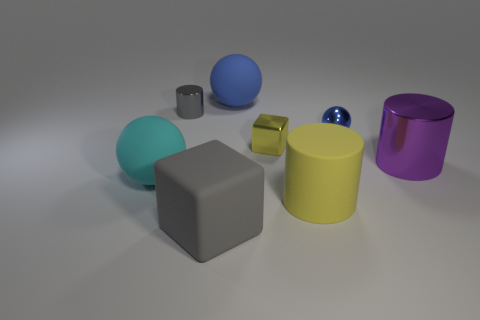Describe the lighting in the scene. The lighting in the scene is soft and diffused, with shadows indicating a light source coming from the upper left, giving the objects gentle highlights and soft-edged shadows on the ground. 